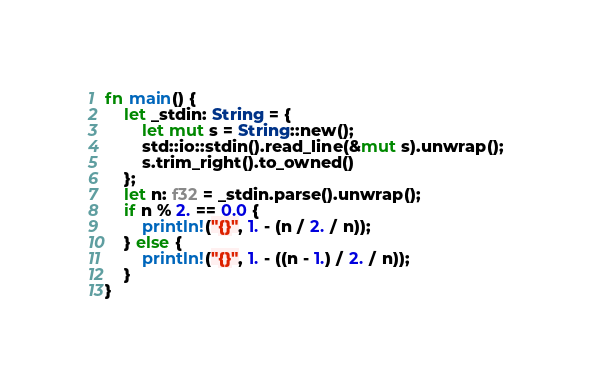Convert code to text. <code><loc_0><loc_0><loc_500><loc_500><_Rust_>fn main() {
    let _stdin: String = {
        let mut s = String::new();
        std::io::stdin().read_line(&mut s).unwrap();
        s.trim_right().to_owned()
    };
    let n: f32 = _stdin.parse().unwrap();
    if n % 2. == 0.0 {
        println!("{}", 1. - (n / 2. / n));
    } else {
        println!("{}", 1. - ((n - 1.) / 2. / n));
    }
}
</code> 